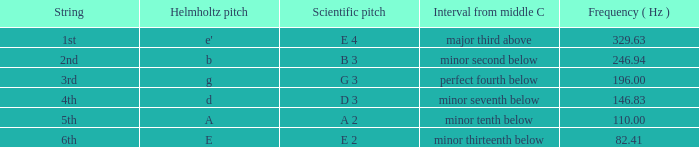What is the scientific pitch when the Helmholtz pitch is D? D 3. 